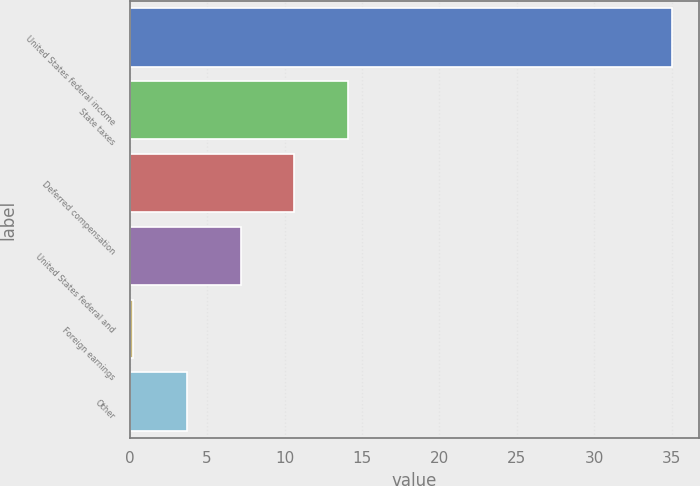Convert chart. <chart><loc_0><loc_0><loc_500><loc_500><bar_chart><fcel>United States federal income<fcel>State taxes<fcel>Deferred compensation<fcel>United States federal and<fcel>Foreign earnings<fcel>Other<nl><fcel>35<fcel>14.12<fcel>10.64<fcel>7.16<fcel>0.2<fcel>3.68<nl></chart> 